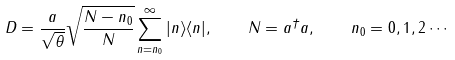<formula> <loc_0><loc_0><loc_500><loc_500>D = \frac { a } { \sqrt { \theta } } \sqrt { \frac { N - n _ { 0 } } { N } } \sum _ { n = n _ { 0 } } ^ { \infty } | n \rangle \langle n | , \quad N = a ^ { \dagger } a , \quad n _ { 0 } = 0 , 1 , 2 \cdots</formula> 